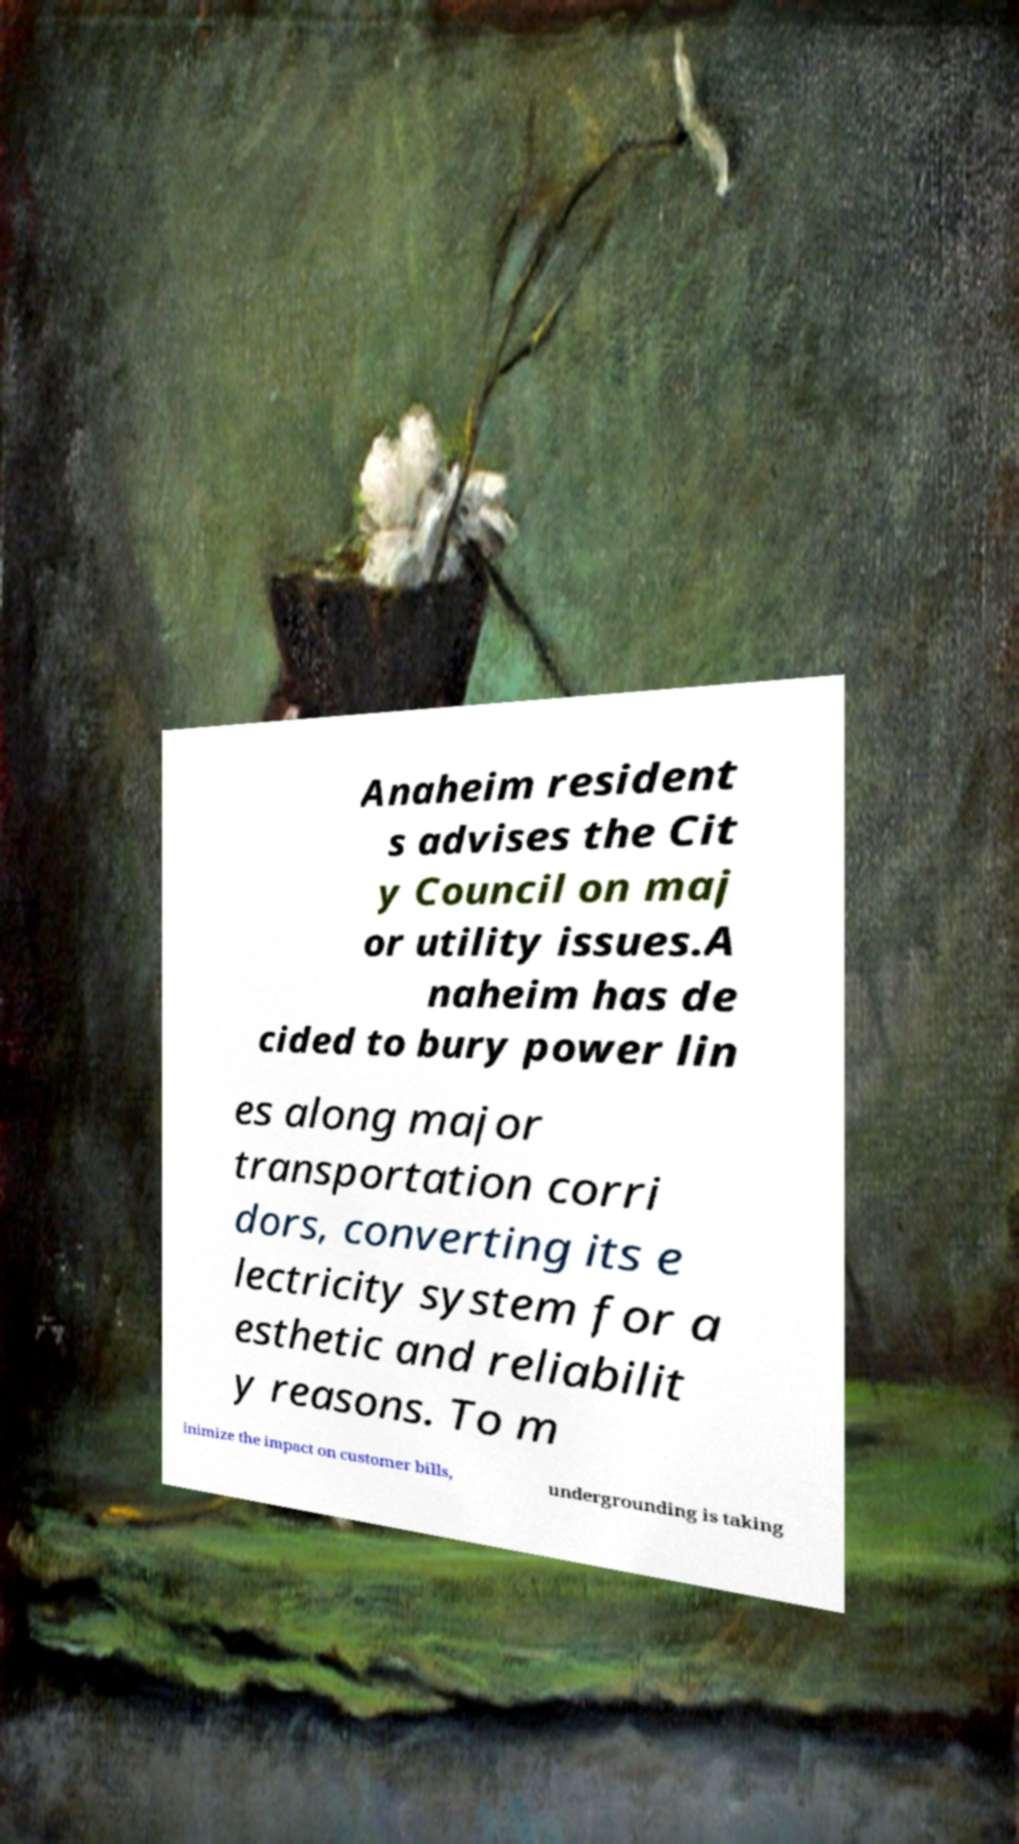Please identify and transcribe the text found in this image. Anaheim resident s advises the Cit y Council on maj or utility issues.A naheim has de cided to bury power lin es along major transportation corri dors, converting its e lectricity system for a esthetic and reliabilit y reasons. To m inimize the impact on customer bills, undergrounding is taking 